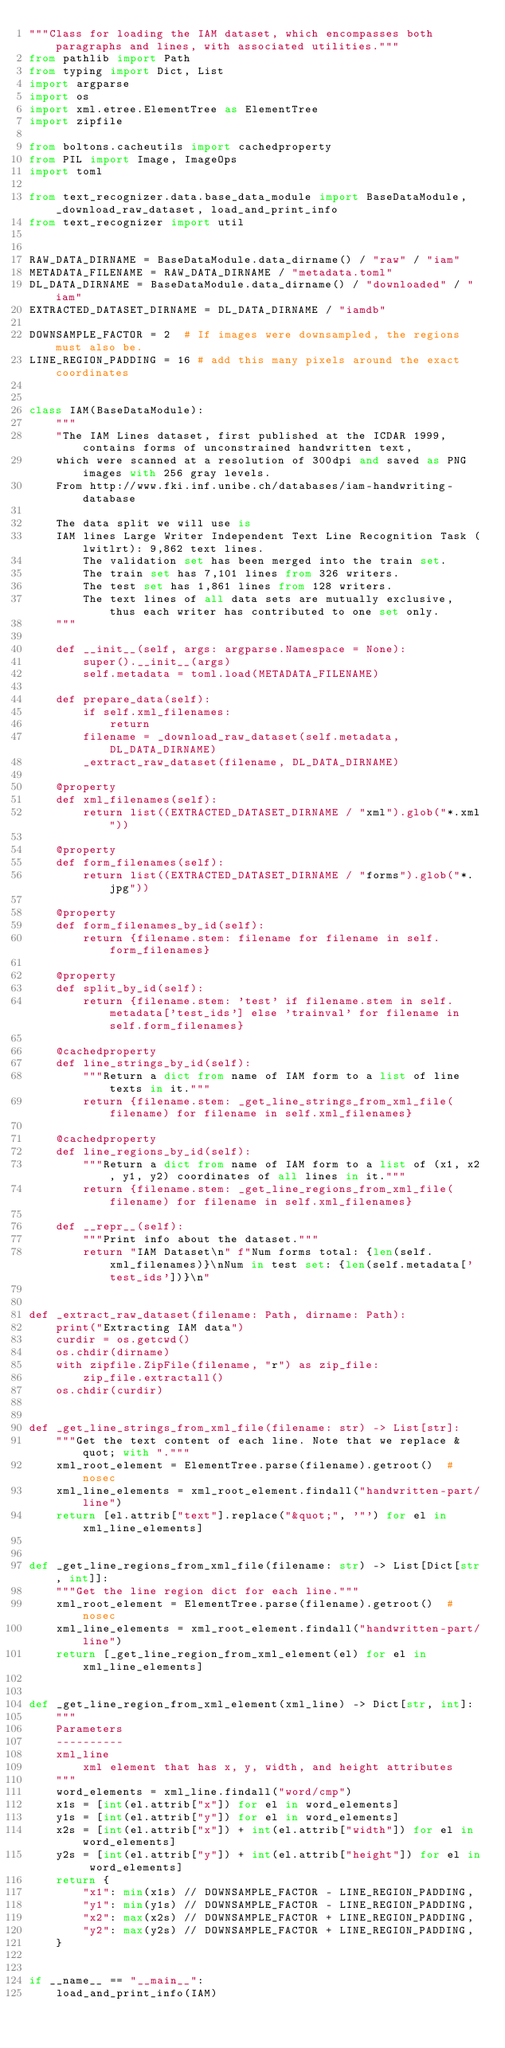<code> <loc_0><loc_0><loc_500><loc_500><_Python_>"""Class for loading the IAM dataset, which encompasses both paragraphs and lines, with associated utilities."""
from pathlib import Path
from typing import Dict, List
import argparse
import os
import xml.etree.ElementTree as ElementTree
import zipfile

from boltons.cacheutils import cachedproperty
from PIL import Image, ImageOps
import toml

from text_recognizer.data.base_data_module import BaseDataModule, _download_raw_dataset, load_and_print_info
from text_recognizer import util


RAW_DATA_DIRNAME = BaseDataModule.data_dirname() / "raw" / "iam"
METADATA_FILENAME = RAW_DATA_DIRNAME / "metadata.toml"
DL_DATA_DIRNAME = BaseDataModule.data_dirname() / "downloaded" / "iam"
EXTRACTED_DATASET_DIRNAME = DL_DATA_DIRNAME / "iamdb"

DOWNSAMPLE_FACTOR = 2  # If images were downsampled, the regions must also be.
LINE_REGION_PADDING = 16 # add this many pixels around the exact coordinates


class IAM(BaseDataModule):
    """
    "The IAM Lines dataset, first published at the ICDAR 1999, contains forms of unconstrained handwritten text,
    which were scanned at a resolution of 300dpi and saved as PNG images with 256 gray levels.
    From http://www.fki.inf.unibe.ch/databases/iam-handwriting-database

    The data split we will use is
    IAM lines Large Writer Independent Text Line Recognition Task (lwitlrt): 9,862 text lines.
        The validation set has been merged into the train set.
        The train set has 7,101 lines from 326 writers.
        The test set has 1,861 lines from 128 writers.
        The text lines of all data sets are mutually exclusive, thus each writer has contributed to one set only.
    """

    def __init__(self, args: argparse.Namespace = None):
        super().__init__(args)
        self.metadata = toml.load(METADATA_FILENAME)

    def prepare_data(self):
        if self.xml_filenames:
            return
        filename = _download_raw_dataset(self.metadata, DL_DATA_DIRNAME)
        _extract_raw_dataset(filename, DL_DATA_DIRNAME)

    @property
    def xml_filenames(self):
        return list((EXTRACTED_DATASET_DIRNAME / "xml").glob("*.xml"))

    @property
    def form_filenames(self):
        return list((EXTRACTED_DATASET_DIRNAME / "forms").glob("*.jpg"))

    @property
    def form_filenames_by_id(self):
        return {filename.stem: filename for filename in self.form_filenames}

    @property
    def split_by_id(self):
        return {filename.stem: 'test' if filename.stem in self.metadata['test_ids'] else 'trainval' for filename in self.form_filenames}

    @cachedproperty
    def line_strings_by_id(self):
        """Return a dict from name of IAM form to a list of line texts in it."""
        return {filename.stem: _get_line_strings_from_xml_file(filename) for filename in self.xml_filenames}

    @cachedproperty
    def line_regions_by_id(self):
        """Return a dict from name of IAM form to a list of (x1, x2, y1, y2) coordinates of all lines in it."""
        return {filename.stem: _get_line_regions_from_xml_file(filename) for filename in self.xml_filenames}

    def __repr__(self):
        """Print info about the dataset."""
        return "IAM Dataset\n" f"Num forms total: {len(self.xml_filenames)}\nNum in test set: {len(self.metadata['test_ids'])}\n"


def _extract_raw_dataset(filename: Path, dirname: Path):
    print("Extracting IAM data")
    curdir = os.getcwd()
    os.chdir(dirname)
    with zipfile.ZipFile(filename, "r") as zip_file:
        zip_file.extractall()
    os.chdir(curdir)


def _get_line_strings_from_xml_file(filename: str) -> List[str]:
    """Get the text content of each line. Note that we replace &quot; with "."""
    xml_root_element = ElementTree.parse(filename).getroot()  # nosec
    xml_line_elements = xml_root_element.findall("handwritten-part/line")
    return [el.attrib["text"].replace("&quot;", '"') for el in xml_line_elements]


def _get_line_regions_from_xml_file(filename: str) -> List[Dict[str, int]]:
    """Get the line region dict for each line."""
    xml_root_element = ElementTree.parse(filename).getroot()  # nosec
    xml_line_elements = xml_root_element.findall("handwritten-part/line")
    return [_get_line_region_from_xml_element(el) for el in xml_line_elements]


def _get_line_region_from_xml_element(xml_line) -> Dict[str, int]:
    """
    Parameters
    ----------
    xml_line
        xml element that has x, y, width, and height attributes
    """
    word_elements = xml_line.findall("word/cmp")
    x1s = [int(el.attrib["x"]) for el in word_elements]
    y1s = [int(el.attrib["y"]) for el in word_elements]
    x2s = [int(el.attrib["x"]) + int(el.attrib["width"]) for el in word_elements]
    y2s = [int(el.attrib["y"]) + int(el.attrib["height"]) for el in word_elements]
    return {
        "x1": min(x1s) // DOWNSAMPLE_FACTOR - LINE_REGION_PADDING,
        "y1": min(y1s) // DOWNSAMPLE_FACTOR - LINE_REGION_PADDING,
        "x2": max(x2s) // DOWNSAMPLE_FACTOR + LINE_REGION_PADDING,
        "y2": max(y2s) // DOWNSAMPLE_FACTOR + LINE_REGION_PADDING,
    }


if __name__ == "__main__":
    load_and_print_info(IAM)
</code> 